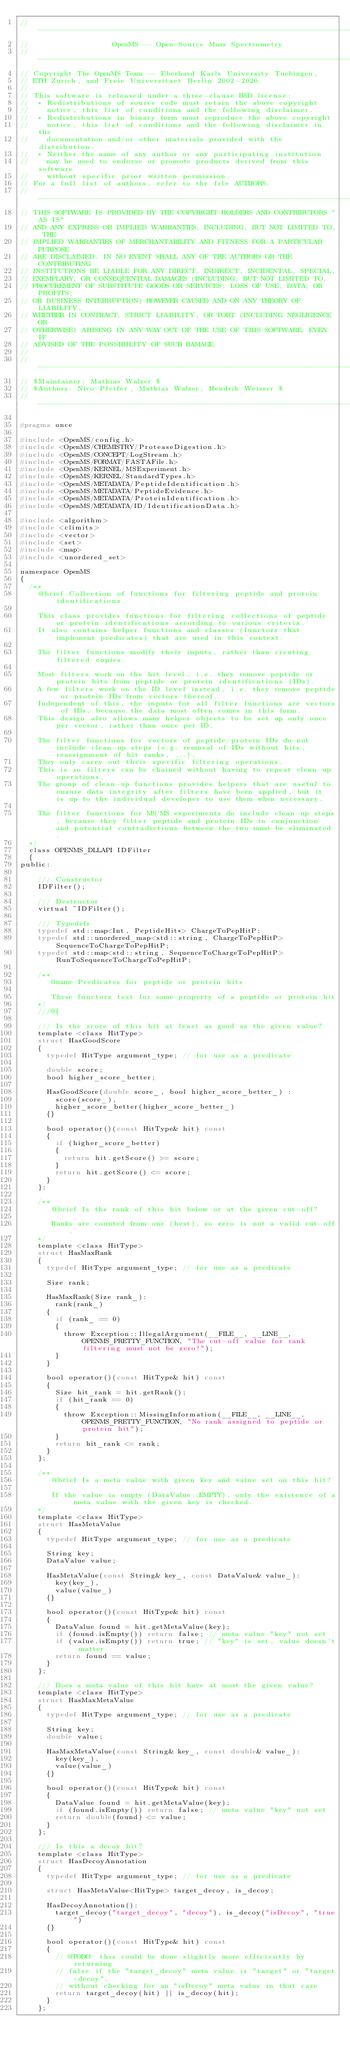Convert code to text. <code><loc_0><loc_0><loc_500><loc_500><_C_>// --------------------------------------------------------------------------
//                   OpenMS -- Open-Source Mass Spectrometry
// --------------------------------------------------------------------------
// Copyright The OpenMS Team -- Eberhard Karls University Tuebingen,
// ETH Zurich, and Freie Universitaet Berlin 2002-2020.
//
// This software is released under a three-clause BSD license:
//  * Redistributions of source code must retain the above copyright
//    notice, this list of conditions and the following disclaimer.
//  * Redistributions in binary form must reproduce the above copyright
//    notice, this list of conditions and the following disclaimer in the
//    documentation and/or other materials provided with the distribution.
//  * Neither the name of any author or any participating institution
//    may be used to endorse or promote products derived from this software
//    without specific prior written permission.
// For a full list of authors, refer to the file AUTHORS.
// --------------------------------------------------------------------------
// THIS SOFTWARE IS PROVIDED BY THE COPYRIGHT HOLDERS AND CONTRIBUTORS "AS IS"
// AND ANY EXPRESS OR IMPLIED WARRANTIES, INCLUDING, BUT NOT LIMITED TO, THE
// IMPLIED WARRANTIES OF MERCHANTABILITY AND FITNESS FOR A PARTICULAR PURPOSE
// ARE DISCLAIMED. IN NO EVENT SHALL ANY OF THE AUTHORS OR THE CONTRIBUTING
// INSTITUTIONS BE LIABLE FOR ANY DIRECT, INDIRECT, INCIDENTAL, SPECIAL,
// EXEMPLARY, OR CONSEQUENTIAL DAMAGES (INCLUDING, BUT NOT LIMITED TO,
// PROCUREMENT OF SUBSTITUTE GOODS OR SERVICES; LOSS OF USE, DATA, OR PROFITS;
// OR BUSINESS INTERRUPTION) HOWEVER CAUSED AND ON ANY THEORY OF LIABILITY,
// WHETHER IN CONTRACT, STRICT LIABILITY, OR TORT (INCLUDING NEGLIGENCE OR
// OTHERWISE) ARISING IN ANY WAY OUT OF THE USE OF THIS SOFTWARE, EVEN IF
// ADVISED OF THE POSSIBILITY OF SUCH DAMAGE.
//
// --------------------------------------------------------------------------
// $Maintainer: Mathias Walzer $
// $Authors: Nico Pfeifer, Mathias Walzer, Hendrik Weisser $
// --------------------------------------------------------------------------

#pragma once

#include <OpenMS/config.h>
#include <OpenMS/CHEMISTRY/ProteaseDigestion.h>
#include <OpenMS/CONCEPT/LogStream.h>
#include <OpenMS/FORMAT/FASTAFile.h>
#include <OpenMS/KERNEL/MSExperiment.h>
#include <OpenMS/KERNEL/StandardTypes.h>
#include <OpenMS/METADATA/PeptideIdentification.h>
#include <OpenMS/METADATA/PeptideEvidence.h>
#include <OpenMS/METADATA/ProteinIdentification.h>
#include <OpenMS/METADATA/ID/IdentificationData.h>

#include <algorithm>
#include <climits>
#include <vector>
#include <set>
#include <map>
#include <unordered_set>

namespace OpenMS
{
  /**
    @brief Collection of functions for filtering peptide and protein identifications.

    This class provides functions for filtering collections of peptide or protein identifications according to various criteria.
    It also contains helper functions and classes (functors that implement predicates) that are used in this context.

    The filter functions modify their inputs, rather than creating filtered copies.

    Most filters work on the hit level, i.e. they remove peptide or protein hits from peptide or protein identifications (IDs).
    A few filters work on the ID level instead, i.e. they remove peptide or protein IDs from vectors thereof.
    Independent of this, the inputs for all filter functions are vectors of IDs, because the data most often comes in this form.
    This design also allows many helper objects to be set up only once per vector, rather than once per ID.

    The filter functions for vectors of peptide/protein IDs do not include clean-up steps (e.g. removal of IDs without hits, reassignment of hit ranks, ...).
    They only carry out their specific filtering operations.
    This is so filters can be chained without having to repeat clean-up operations.
    The group of clean-up functions provides helpers that are useful to ensure data integrity after filters have been applied, but it is up to the individual developer to use them when necessary.

    The filter functions for MS/MS experiments do include clean-up steps, because they filter peptide and protein IDs in conjunction and potential contradictions between the two must be eliminated.
  */
  class OPENMS_DLLAPI IDFilter
  {
public:

    /// Constructor
    IDFilter();

    /// Destructor
    virtual ~IDFilter();

    /// Typedefs
    typedef std::map<Int, PeptideHit*> ChargeToPepHitP;
    typedef std::unordered_map<std::string, ChargeToPepHitP> SequenceToChargeToPepHitP;
    typedef std::map<std::string, SequenceToChargeToPepHitP> RunToSequenceToChargeToPepHitP;

    /**
       @name Predicates for peptide or protein hits

       These functors test for some property of a peptide or protein hit
    */
    ///@{

    /// Is the score of this hit at least as good as the given value?
    template <class HitType>
    struct HasGoodScore
    {
      typedef HitType argument_type; // for use as a predicate

      double score;
      bool higher_score_better;

      HasGoodScore(double score_, bool higher_score_better_) :
        score(score_),
        higher_score_better(higher_score_better_)
      {}

      bool operator()(const HitType& hit) const
      {
        if (higher_score_better)
        {
          return hit.getScore() >= score;
        }
        return hit.getScore() <= score;
      }
    };

    /**
       @brief Is the rank of this hit below or at the given cut-off?

       Ranks are counted from one (best), so zero is not a valid cut-off.
    */
    template <class HitType>
    struct HasMaxRank
    {
      typedef HitType argument_type; // for use as a predicate

      Size rank;

      HasMaxRank(Size rank_):
        rank(rank_)
      {
        if (rank_ == 0)
        {
          throw Exception::IllegalArgument(__FILE__, __LINE__, OPENMS_PRETTY_FUNCTION, "The cut-off value for rank filtering must not be zero!");
        }
      }

      bool operator()(const HitType& hit) const
      {
        Size hit_rank = hit.getRank();
        if (hit_rank == 0)
        {
          throw Exception::MissingInformation(__FILE__, __LINE__, OPENMS_PRETTY_FUNCTION, "No rank assigned to peptide or protein hit");
        }
        return hit_rank <= rank;
      }
    };

    /**
       @brief Is a meta value with given key and value set on this hit?

       If the value is empty (DataValue::EMPTY), only the existence of a meta value with the given key is checked.
    */
    template <class HitType>
    struct HasMetaValue
    {
      typedef HitType argument_type; // for use as a predicate

      String key;
      DataValue value;

      HasMetaValue(const String& key_, const DataValue& value_):
        key(key_),
        value(value_)
      {}

      bool operator()(const HitType& hit) const
      {
        DataValue found = hit.getMetaValue(key);
        if (found.isEmpty()) return false; // meta value "key" not set
        if (value.isEmpty()) return true; // "key" is set, value doesn't matter
        return found == value;
      }
    };

    /// Does a meta value of this hit have at most the given value?
    template <class HitType>
    struct HasMaxMetaValue
    {
      typedef HitType argument_type; // for use as a predicate

      String key;
      double value;

      HasMaxMetaValue(const String& key_, const double& value_):
        key(key_),
        value(value_)
      {}

      bool operator()(const HitType& hit) const
      {
        DataValue found = hit.getMetaValue(key);
        if (found.isEmpty()) return false; // meta value "key" not set
        return double(found) <= value;
      }
    };

    /// Is this a decoy hit?
    template <class HitType>
    struct HasDecoyAnnotation
    {
      typedef HitType argument_type; // for use as a predicate

      struct HasMetaValue<HitType> target_decoy, is_decoy;

      HasDecoyAnnotation():
        target_decoy("target_decoy", "decoy"), is_decoy("isDecoy", "true")
      {}

      bool operator()(const HitType& hit) const
      {
        // @TODO: this could be done slightly more efficiently by returning
        // false if the "target_decoy" meta value is "target" or "target+decoy",
        // without checking for an "isDecoy" meta value in that case
        return target_decoy(hit) || is_decoy(hit);
      }
    };
</code> 